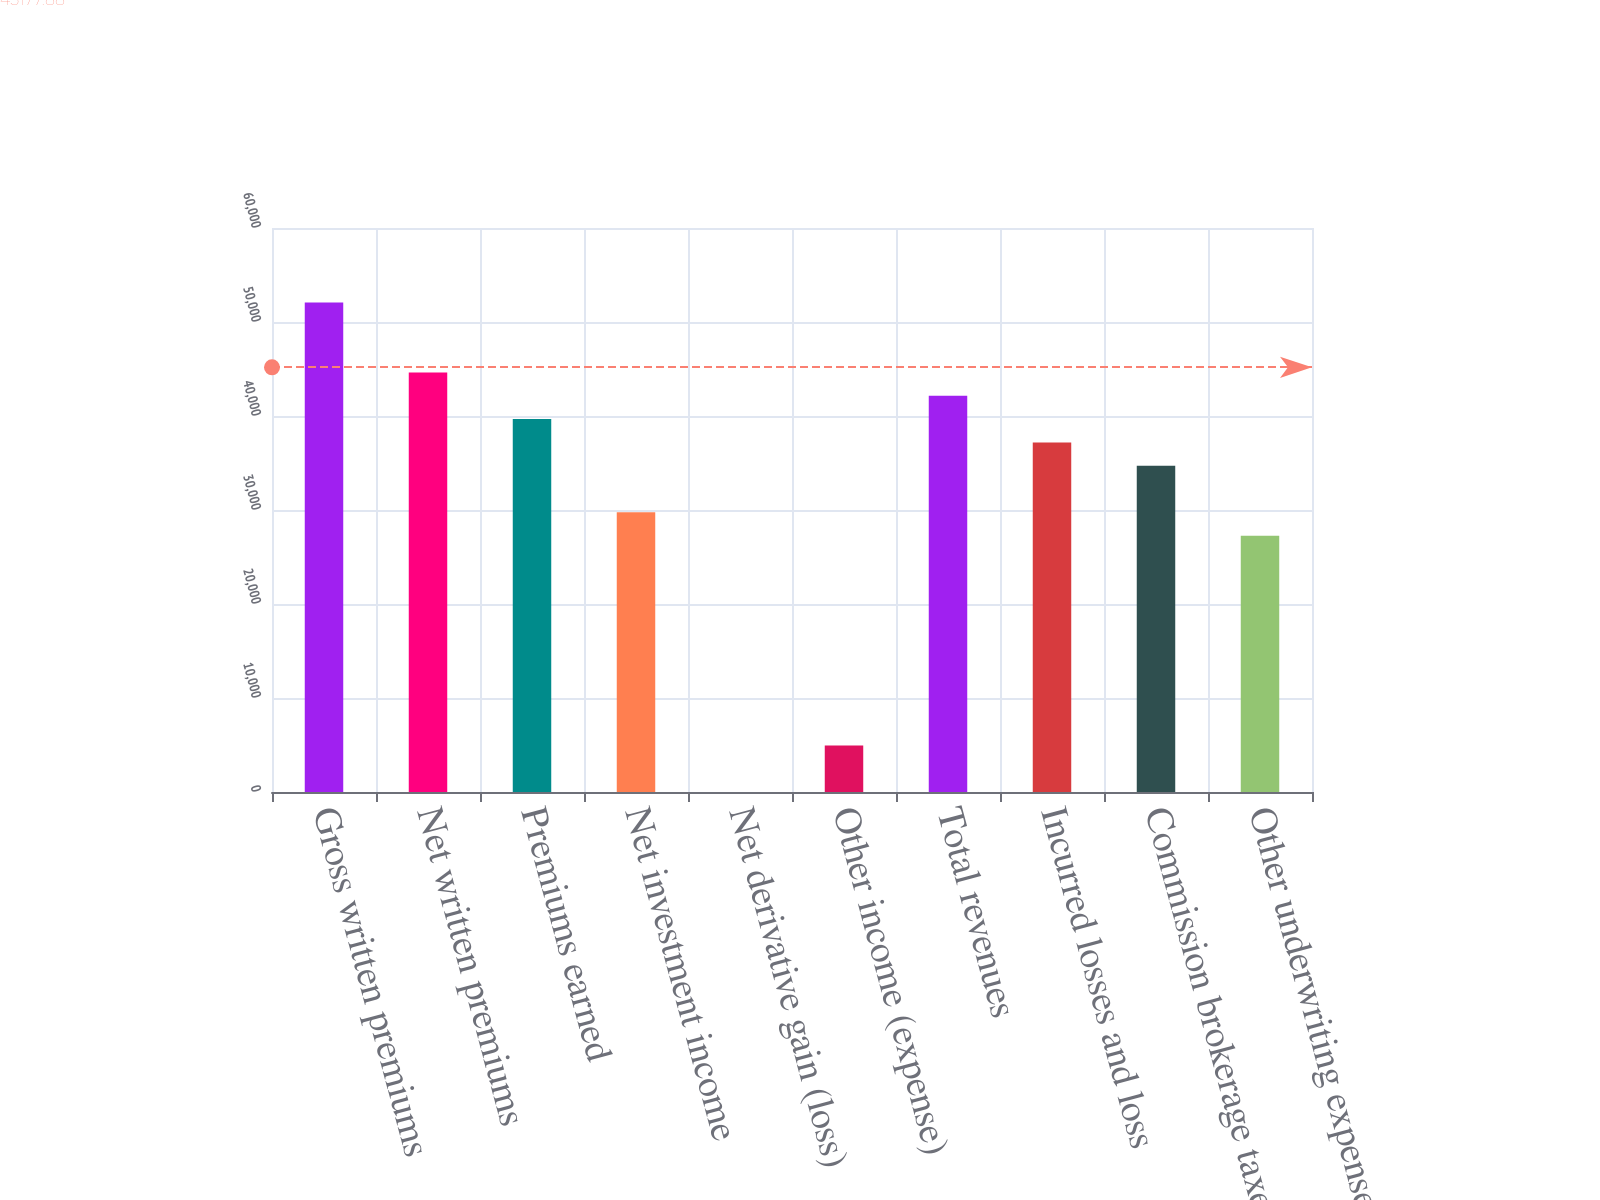Convert chart. <chart><loc_0><loc_0><loc_500><loc_500><bar_chart><fcel>Gross written premiums<fcel>Net written premiums<fcel>Premiums earned<fcel>Net investment income<fcel>Net derivative gain (loss)<fcel>Other income (expense)<fcel>Total revenues<fcel>Incurred losses and loss<fcel>Commission brokerage taxes and<fcel>Other underwriting expenses<nl><fcel>52066.8<fcel>44628.8<fcel>39670.1<fcel>29752.7<fcel>0.5<fcel>4959.2<fcel>42149.4<fcel>37190.8<fcel>34711.4<fcel>27273.3<nl></chart> 